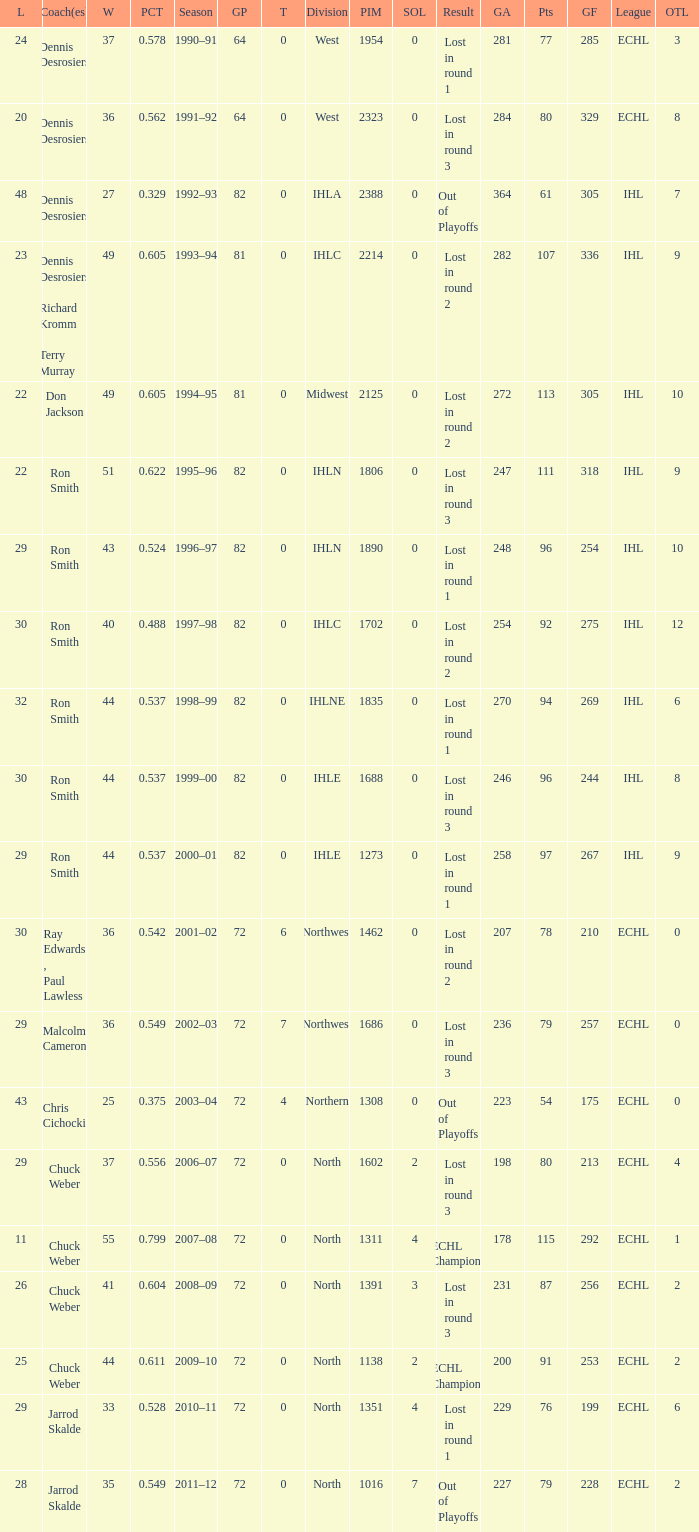How many season did the team lost in round 1 with a GP of 64? 1.0. 